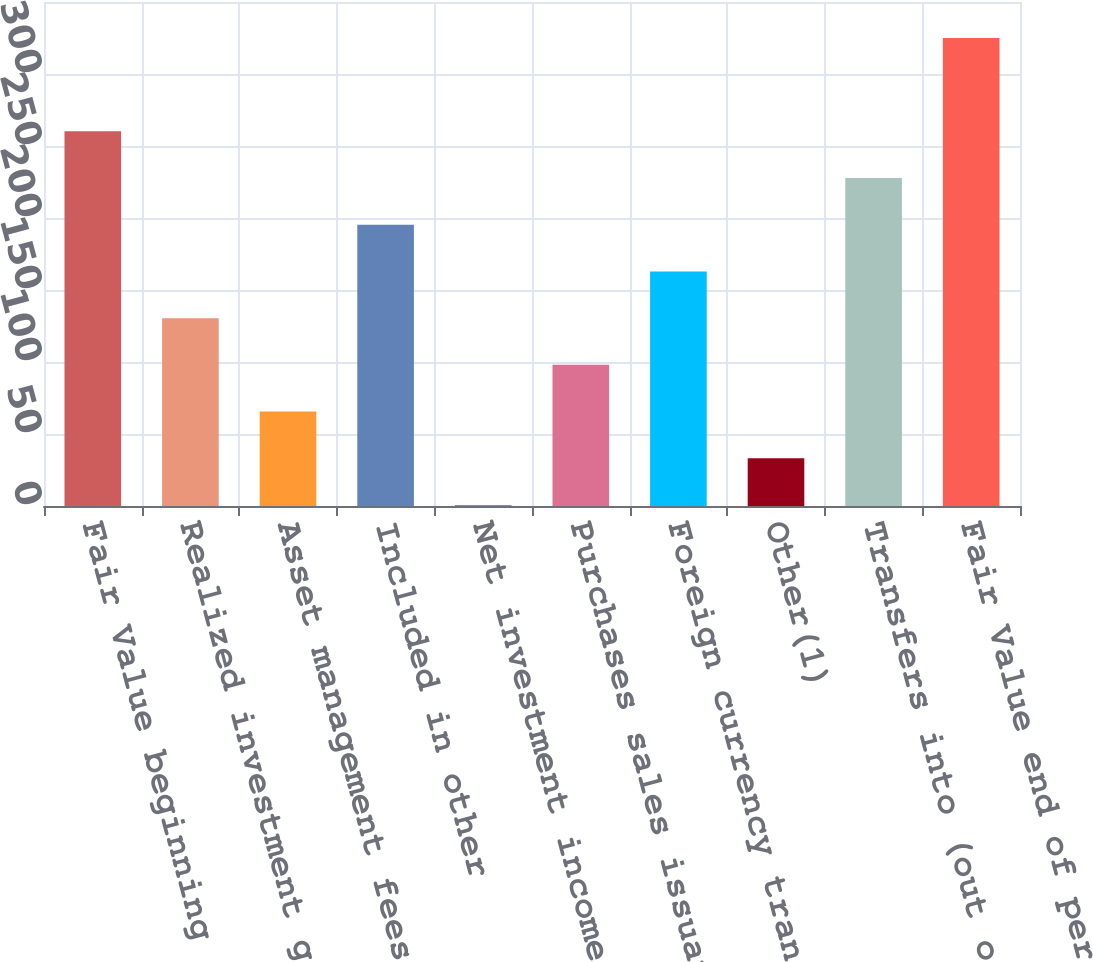Convert chart to OTSL. <chart><loc_0><loc_0><loc_500><loc_500><bar_chart><fcel>Fair Value beginning of period<fcel>Realized investment gains<fcel>Asset management fees and<fcel>Included in other<fcel>Net investment income<fcel>Purchases sales issuances and<fcel>Foreign currency translation<fcel>Other(1)<fcel>Transfers into (out of) Level<fcel>Fair Value end of period<nl><fcel>260.16<fcel>130.44<fcel>65.58<fcel>195.3<fcel>0.72<fcel>98.01<fcel>162.87<fcel>33.15<fcel>227.73<fcel>325<nl></chart> 